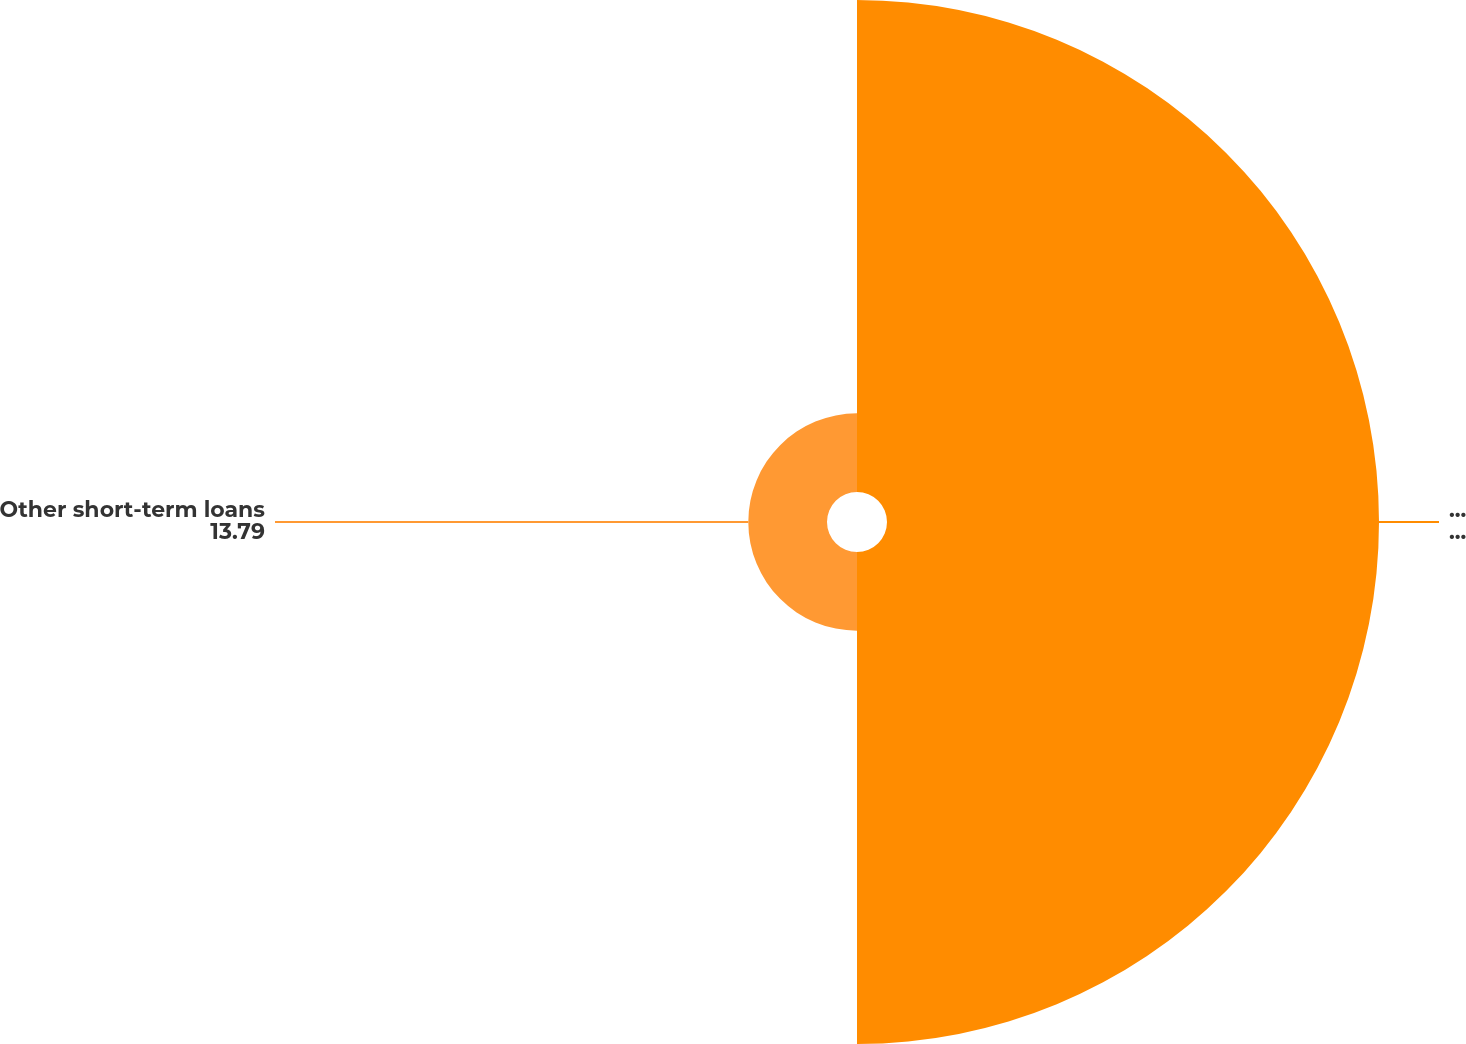Convert chart. <chart><loc_0><loc_0><loc_500><loc_500><pie_chart><fcel>Brazil short-term loans<fcel>Other short-term loans<nl><fcel>86.21%<fcel>13.79%<nl></chart> 